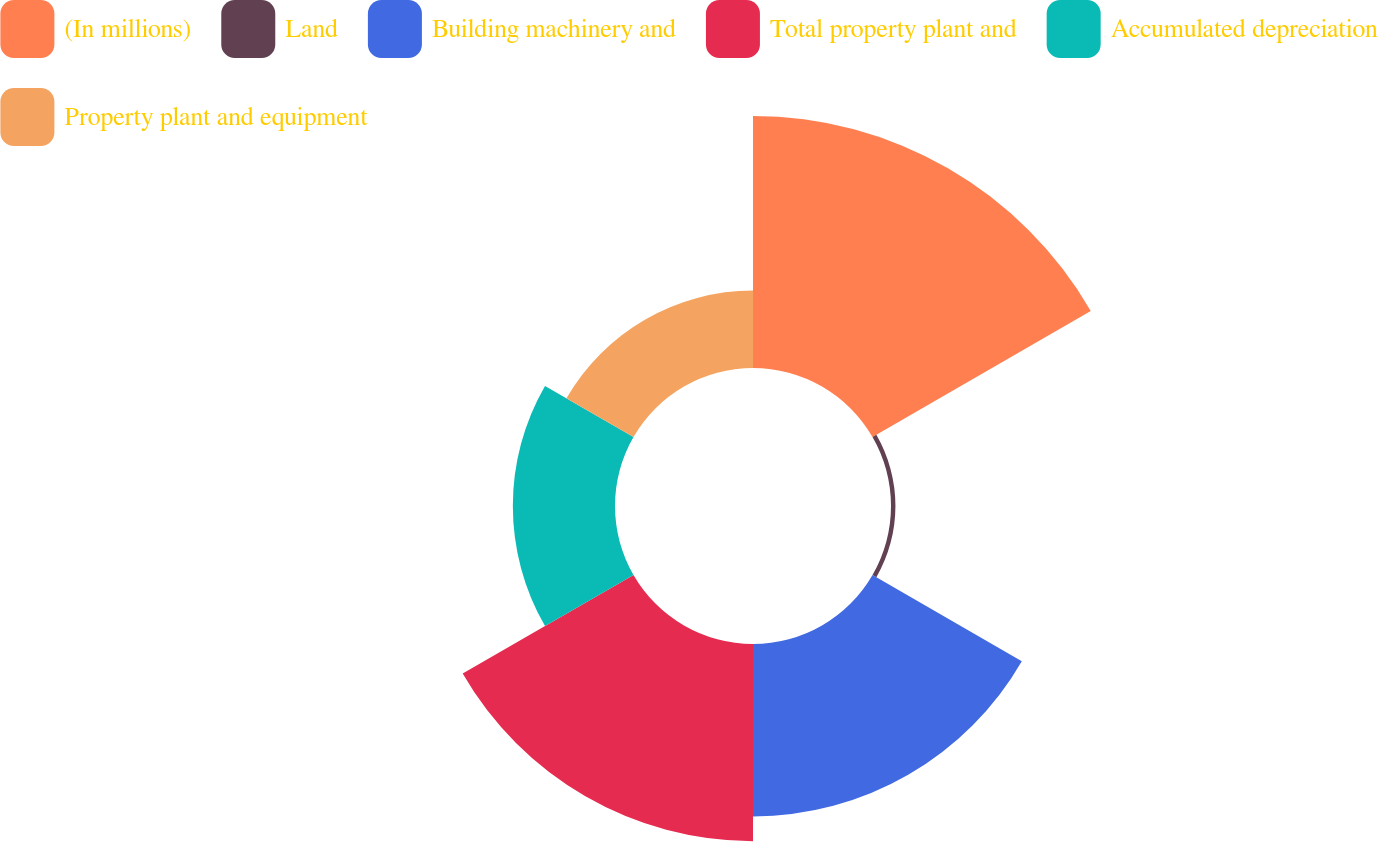Convert chart to OTSL. <chart><loc_0><loc_0><loc_500><loc_500><pie_chart><fcel>(In millions)<fcel>Land<fcel>Building machinery and<fcel>Total property plant and<fcel>Accumulated depreciation<fcel>Property plant and equipment<nl><fcel>31.28%<fcel>0.55%<fcel>21.4%<fcel>24.48%<fcel>12.68%<fcel>9.61%<nl></chart> 